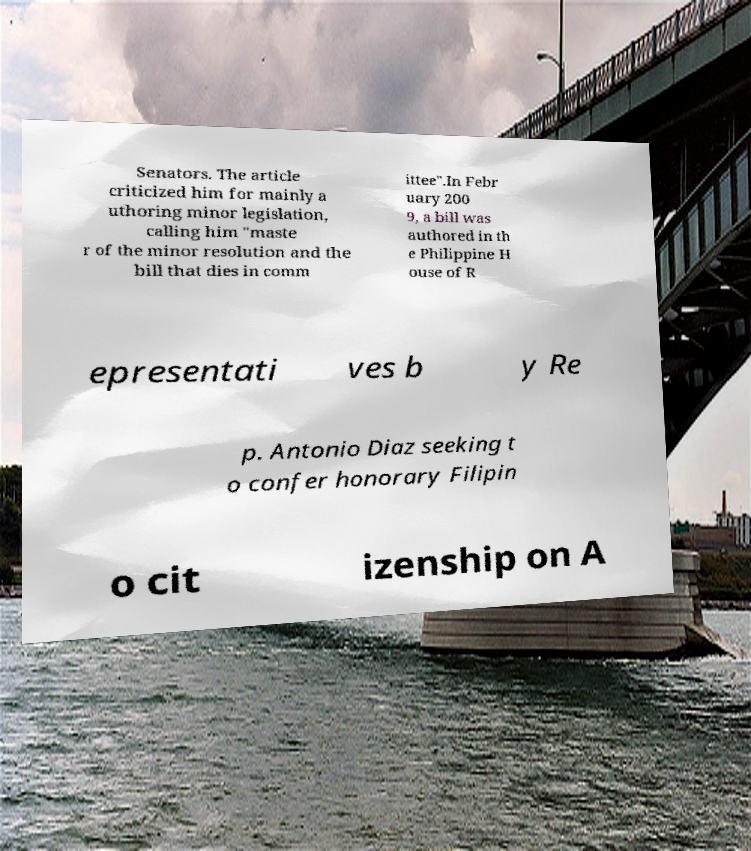Can you accurately transcribe the text from the provided image for me? Senators. The article criticized him for mainly a uthoring minor legislation, calling him "maste r of the minor resolution and the bill that dies in comm ittee".In Febr uary 200 9, a bill was authored in th e Philippine H ouse of R epresentati ves b y Re p. Antonio Diaz seeking t o confer honorary Filipin o cit izenship on A 